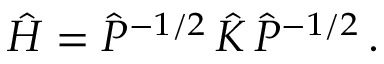<formula> <loc_0><loc_0><loc_500><loc_500>\begin{array} { r } { \hat { H } = \hat { P } ^ { - 1 / 2 } \, \hat { K } \, \hat { P } ^ { - 1 / 2 } \, . } \end{array}</formula> 